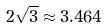<formula> <loc_0><loc_0><loc_500><loc_500>2 \sqrt { 3 } \approx 3 . 4 6 4</formula> 